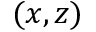Convert formula to latex. <formula><loc_0><loc_0><loc_500><loc_500>( x , z )</formula> 